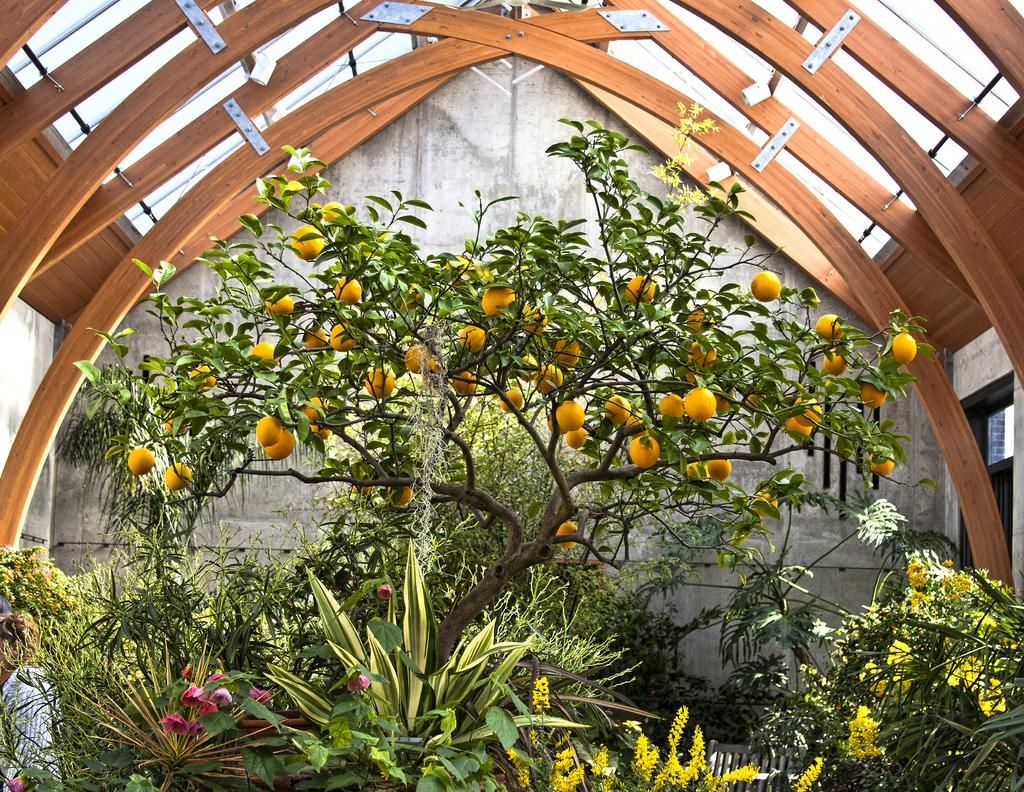What type of plants can be seen in the image? There are houseplants in the image. Can you describe the person in the image? There is a person in the image, but no specific details about their appearance or actions are provided. What type of natural element is present in the image? There is a tree in the image. What type of structure can be seen in the image? There is a wall and a shed in the image. What might be the setting of the image? The image may have been taken in a garden, based on the presence of houseplants, a tree, and possibly a shed. What type of hole can be seen in the image? There is no hole present in the image. What time of day is it in the image? The time of day cannot be determined from the image, as there are no specific details about lighting or shadows. 